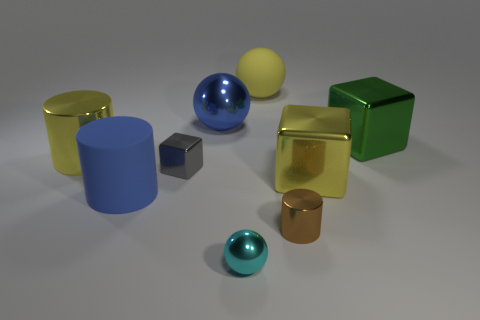Is there any other thing that is the same color as the matte ball?
Your answer should be very brief. Yes. What material is the green thing that is the same shape as the small gray metal object?
Provide a succinct answer. Metal. What number of other things are the same size as the gray metallic thing?
Your answer should be compact. 2. What is the tiny cube made of?
Provide a succinct answer. Metal. Is the number of tiny shiny cylinders that are behind the large green block greater than the number of green spheres?
Offer a very short reply. No. Are there any big cyan rubber balls?
Your answer should be compact. No. What number of other objects are the same shape as the tiny gray thing?
Keep it short and to the point. 2. Is the color of the big cube in front of the yellow cylinder the same as the sphere that is in front of the big green cube?
Ensure brevity in your answer.  No. What is the size of the brown metal thing in front of the blue object behind the large matte thing that is to the left of the large yellow matte thing?
Give a very brief answer. Small. There is a big thing that is both on the right side of the big blue metallic object and behind the green metal block; what is its shape?
Ensure brevity in your answer.  Sphere. 